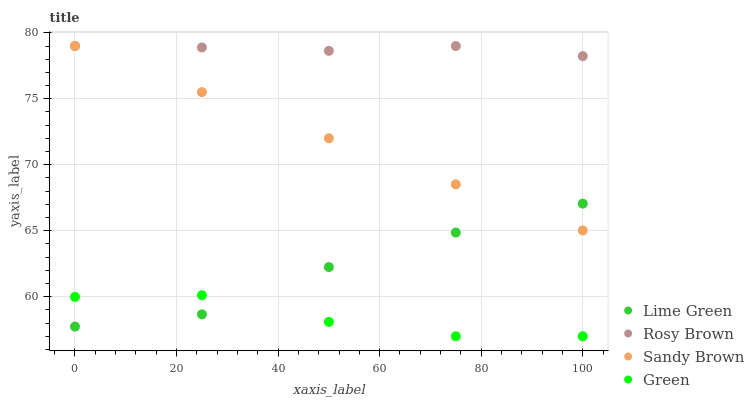Does Green have the minimum area under the curve?
Answer yes or no. Yes. Does Rosy Brown have the maximum area under the curve?
Answer yes or no. Yes. Does Lime Green have the minimum area under the curve?
Answer yes or no. No. Does Lime Green have the maximum area under the curve?
Answer yes or no. No. Is Sandy Brown the smoothest?
Answer yes or no. Yes. Is Green the roughest?
Answer yes or no. Yes. Is Rosy Brown the smoothest?
Answer yes or no. No. Is Rosy Brown the roughest?
Answer yes or no. No. Does Green have the lowest value?
Answer yes or no. Yes. Does Lime Green have the lowest value?
Answer yes or no. No. Does Rosy Brown have the highest value?
Answer yes or no. Yes. Does Lime Green have the highest value?
Answer yes or no. No. Is Green less than Sandy Brown?
Answer yes or no. Yes. Is Sandy Brown greater than Green?
Answer yes or no. Yes. Does Sandy Brown intersect Lime Green?
Answer yes or no. Yes. Is Sandy Brown less than Lime Green?
Answer yes or no. No. Is Sandy Brown greater than Lime Green?
Answer yes or no. No. Does Green intersect Sandy Brown?
Answer yes or no. No. 